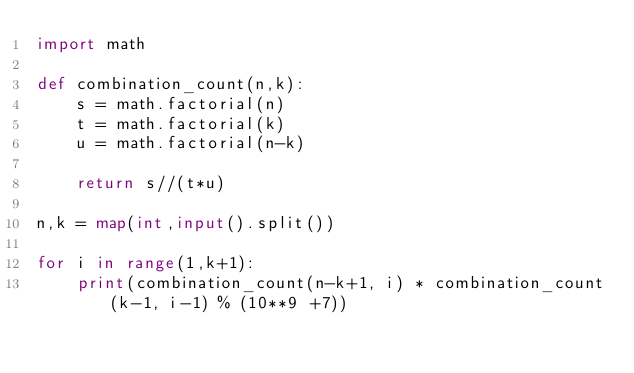Convert code to text. <code><loc_0><loc_0><loc_500><loc_500><_Python_>import math

def combination_count(n,k):
    s = math.factorial(n)
    t = math.factorial(k)
    u = math.factorial(n-k)
    
    return s//(t*u)
    
n,k = map(int,input().split())

for i in range(1,k+1):
    print(combination_count(n-k+1, i) * combination_count(k-1, i-1) % (10**9 +7))</code> 